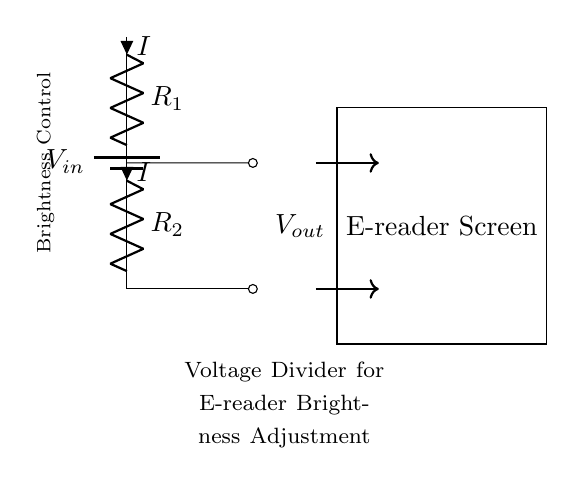What is the type of circuit represented? The circuit is a voltage divider, which is indicated by the two resistors in series connected to a voltage source.
Answer: voltage divider What components are used in this circuit? The circuit consists of a battery and two resistors, denoted as R1 and R2, which are essential for creating a voltage division.
Answer: battery and resistors What is the purpose of the voltage divider here? The voltage divider is used to adjust the brightness of the e-reader screen by providing a lower voltage output from the input voltage.
Answer: brightness control What is the direction of current flow in the circuit? The current flows from the positive terminal of the battery, through R1 and R2, and back to the battery's negative terminal, indicating a closed loop.
Answer: downward How does changing R1 affect the output voltage? Increasing R1 will result in a lower output voltage across R2 due to a larger voltage drop across R1, impacting the brightness.
Answer: lower output voltage If R1 is twice the value of R2, what fraction of the input voltage appears across R2? If R1 is twice R2, the output voltage across R2 will be one-third of the input voltage based on the voltage division rule.
Answer: one-third What is the output voltage relative to the input voltage? The output voltage is dependent on the resistor values R1 and R2, and it is a fraction of the input voltage determined by their ratio.
Answer: fraction of input voltage 